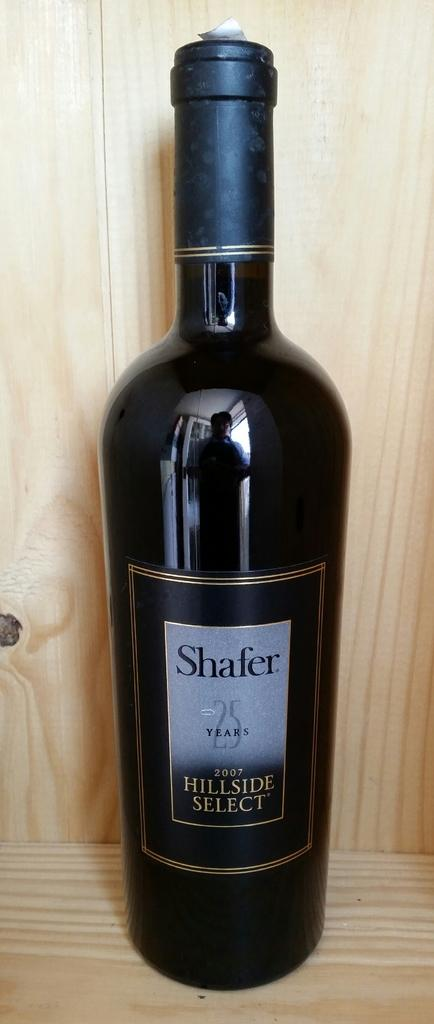<image>
Render a clear and concise summary of the photo. A Hillsid Select style of the Vinyard known as Shafer 